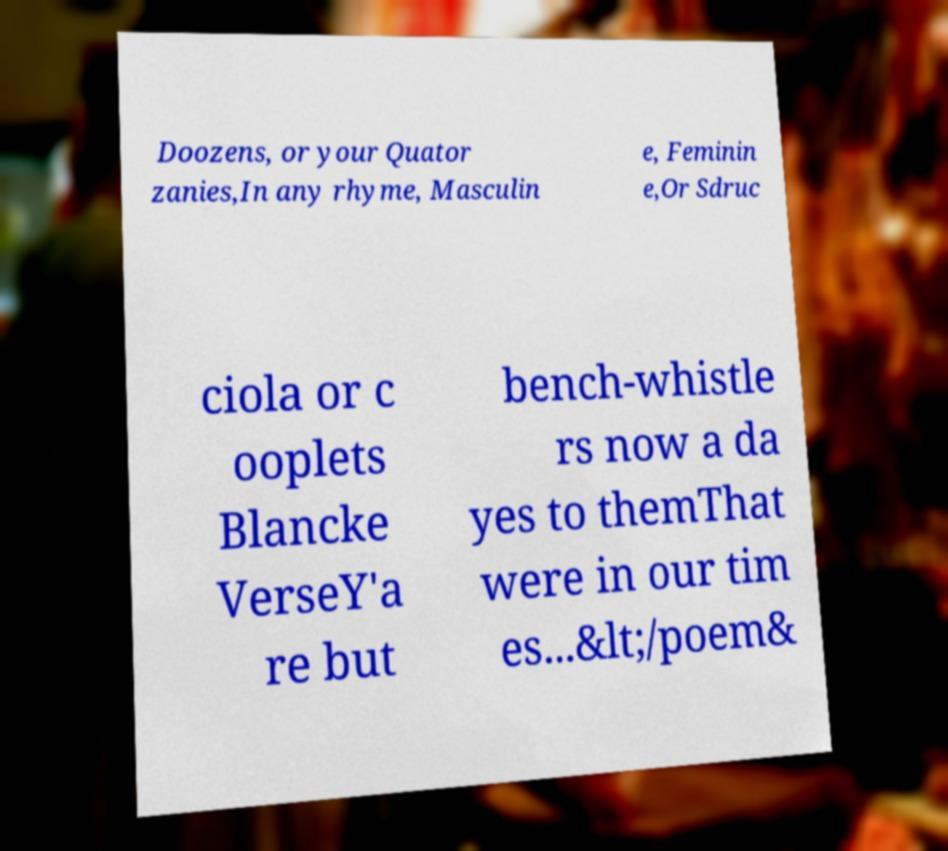Can you accurately transcribe the text from the provided image for me? Doozens, or your Quator zanies,In any rhyme, Masculin e, Feminin e,Or Sdruc ciola or c ooplets Blancke VerseY'a re but bench-whistle rs now a da yes to themThat were in our tim es...&lt;/poem& 